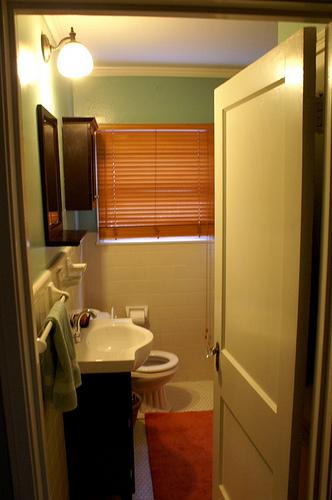How many towels are here?
Keep it brief. 1. Is this in a home or a hotel?
Quick response, please. Home. Is the light on?
Answer briefly. Yes. Is the toilet seat up?
Short answer required. Yes. What color are the blinds?
Quick response, please. Brown. Does this look like a hotel bathroom?
Give a very brief answer. No. 